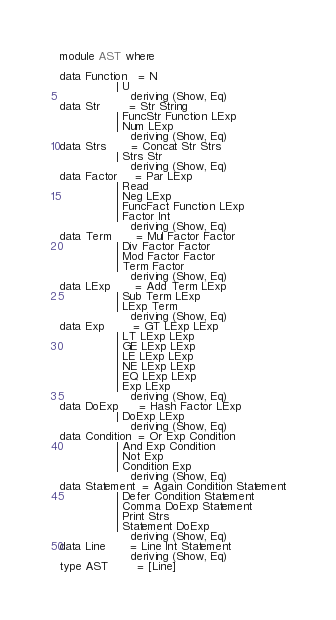Convert code to text. <code><loc_0><loc_0><loc_500><loc_500><_Haskell_>module AST where

data Function   = N
                | U
                    deriving (Show, Eq)
data Str        = Str String
                | FuncStr Function LExp
                | Num LExp
                    deriving (Show, Eq)
data Strs       = Concat Str Strs
                | Strs Str
                    deriving (Show, Eq)
data Factor     = Par LExp
                | Read
                | Neg LExp
                | FuncFact Function LExp
                | Factor Int
                    deriving (Show, Eq)
data Term       = Mul Factor Factor
                | Div Factor Factor
                | Mod Factor Factor
                | Term Factor
                    deriving (Show, Eq)
data LExp       = Add Term LExp
                | Sub Term LExp
                | LExp Term
                    deriving (Show, Eq)
data Exp        = GT LExp LExp
                | LT LExp LExp
                | GE LExp LExp
                | LE LExp LExp
                | NE LExp LExp
                | EQ LExp LExp
                | Exp LExp
                    deriving (Show, Eq)
data DoExp      = Hash Factor LExp
                | DoExp LExp
                    deriving (Show, Eq)
data Condition  = Or Exp Condition
                | And Exp Condition
                | Not Exp
                | Condition Exp
                    deriving (Show, Eq)
data Statement  = Again Condition Statement
                | Defer Condition Statement
                | Comma DoExp Statement
                | Print Strs
                | Statement DoExp
                    deriving (Show, Eq)
data Line       = Line Int Statement
                    deriving (Show, Eq)
type AST        = [Line]</code> 